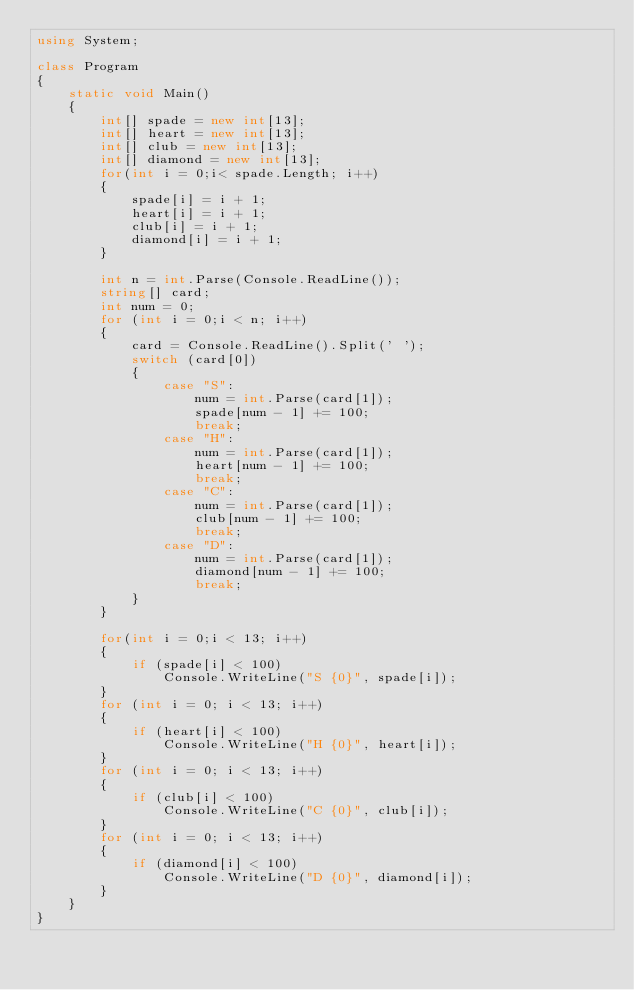Convert code to text. <code><loc_0><loc_0><loc_500><loc_500><_C#_>using System;

class Program
{
    static void Main()
    {
        int[] spade = new int[13];
        int[] heart = new int[13];
        int[] club = new int[13];
        int[] diamond = new int[13];
        for(int i = 0;i< spade.Length; i++)
        {
            spade[i] = i + 1;
            heart[i] = i + 1;
            club[i] = i + 1;
            diamond[i] = i + 1;
        }
        
        int n = int.Parse(Console.ReadLine());
        string[] card;
        int num = 0;
        for (int i = 0;i < n; i++)
        {
            card = Console.ReadLine().Split(' ');
            switch (card[0])
            {
                case "S":
                    num = int.Parse(card[1]);
                    spade[num - 1] += 100;
                    break;
                case "H":
                    num = int.Parse(card[1]);
                    heart[num - 1] += 100;
                    break;
                case "C":
                    num = int.Parse(card[1]);
                    club[num - 1] += 100;
                    break;
                case "D":
                    num = int.Parse(card[1]);
                    diamond[num - 1] += 100;
                    break;
            }
        }

        for(int i = 0;i < 13; i++)
        {
            if (spade[i] < 100)
                Console.WriteLine("S {0}", spade[i]);
        }
        for (int i = 0; i < 13; i++)
        {
            if (heart[i] < 100)
                Console.WriteLine("H {0}", heart[i]);
        }
        for (int i = 0; i < 13; i++)
        {
            if (club[i] < 100)
                Console.WriteLine("C {0}", club[i]);
        }
        for (int i = 0; i < 13; i++)
        {
            if (diamond[i] < 100)
                Console.WriteLine("D {0}", diamond[i]);
        }
    }
}</code> 